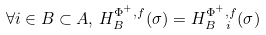Convert formula to latex. <formula><loc_0><loc_0><loc_500><loc_500>\forall i \in B \subset A , \, H _ { B } ^ { \Phi ^ { + } , f } ( \sigma ) = H _ { B \ i } ^ { \Phi ^ { + } , f } ( \sigma )</formula> 